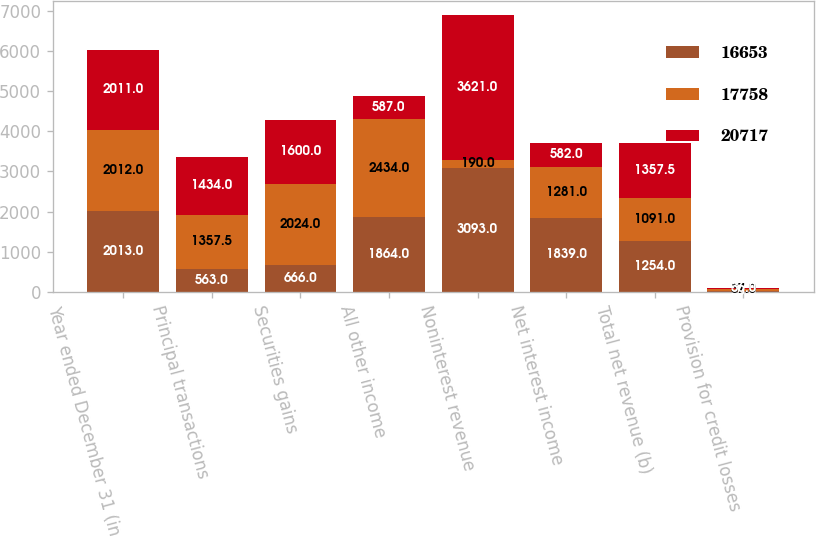Convert chart. <chart><loc_0><loc_0><loc_500><loc_500><stacked_bar_chart><ecel><fcel>Year ended December 31 (in<fcel>Principal transactions<fcel>Securities gains<fcel>All other income<fcel>Noninterest revenue<fcel>Net interest income<fcel>Total net revenue (b)<fcel>Provision for credit losses<nl><fcel>16653<fcel>2013<fcel>563<fcel>666<fcel>1864<fcel>3093<fcel>1839<fcel>1254<fcel>28<nl><fcel>17758<fcel>2012<fcel>1357.5<fcel>2024<fcel>2434<fcel>190<fcel>1281<fcel>1091<fcel>37<nl><fcel>20717<fcel>2011<fcel>1434<fcel>1600<fcel>587<fcel>3621<fcel>582<fcel>1357.5<fcel>36<nl></chart> 